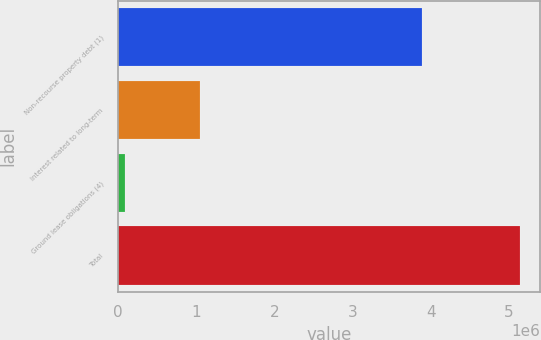<chart> <loc_0><loc_0><loc_500><loc_500><bar_chart><fcel>Non-recourse property debt (1)<fcel>Interest related to long-term<fcel>Ground lease obligations (4)<fcel>Total<nl><fcel>3.88965e+06<fcel>1.05244e+06<fcel>88057<fcel>5.1418e+06<nl></chart> 